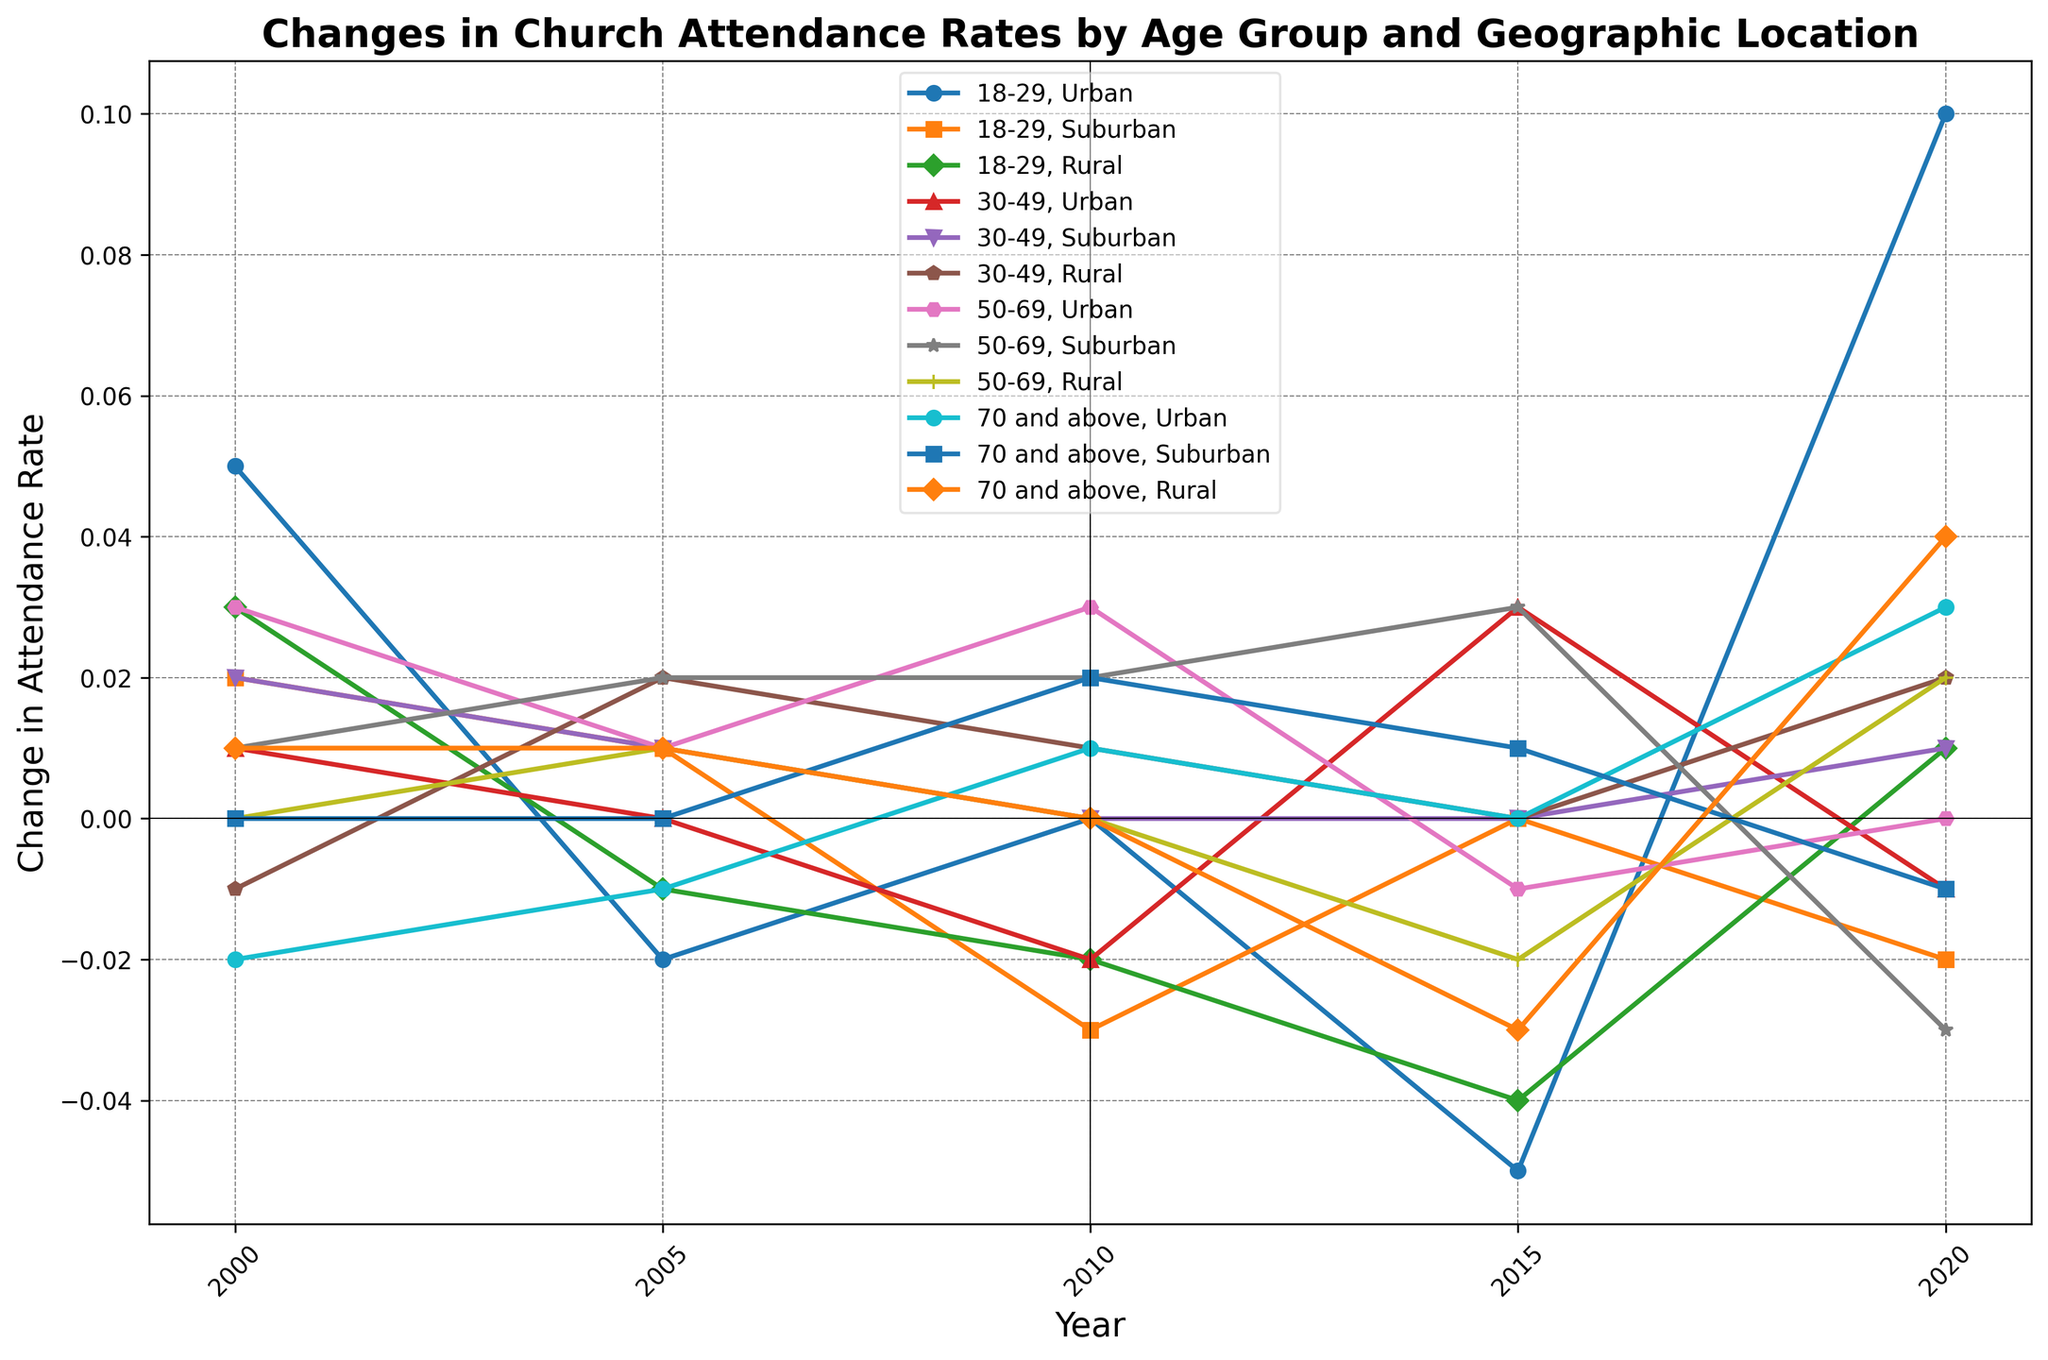What's the trend in church attendance changes for the 18-29 age group in rural areas from 2000 to 2020? The changes in attendance rates for the 18-29 age group in rural areas over the years are as follows: 0.03 (2000), -0.01 (2005), -0.02 (2010), -0.04 (2015), and 0.01 (2020). Despite fluctuations, the attendance generally shows a declining trend with a slight increase in 2020.
Answer: General decline with slight increase in 2020 Which age group and location show the highest increase in church attendance between 2015 and 2020? To find the highest increase, compare the differences between the 2015 and 2020 data for all age group and location combinations. The 70+ age group in Rural areas shows the most significant increase from -0.03 to 0.04, which is a difference of 0.07.
Answer: 70 and above, Rural What was the change in church attendance for the 30-49 age group in urban areas between 2000 and 2020? The attendance rate for the 30-49 age group in urban areas changed from 0.01 in 2000 to -0.01 in 2020. The difference is -0.01 - 0.01 = -0.02.
Answer: -0.02 Comparing the 50-69 age group in suburban and rural areas, which one had a higher change in attendance rate in 2010? In 2010, the change for the 50-69 age group was 0.02 in Suburban areas and 0.00 in Rural areas. Hence, the suburban area had a higher change in attendance.
Answer: Suburban Between 2000 and 2015 for the 18-29 age group, which location saw the least fluctuation in church attendance? We look at the absolute changes in each year for each location (Urban, Suburban, Rural). The least fluctuation comes from Suburban areas with change values of 0.02, 0.01, -0.03, 0.00, totaling 0.06, compared to Urban (total 0.15) and Rural (total 0.10).
Answer: Suburban Which age group and location combination experienced the largest drop in church attendance between the first and last recorded years? To find the largest drop: calculate the differences from 2000 to 2020 for all combinations. The 50-69 age group in Suburban areas fell from 0.01 to -0.03, a drop of -0.04.
Answer: 50-69, Suburban What was the average attendance rate change in rural areas across all age groups in 2020? Calculate the average of the 2020 changes for all age groups in Rural areas: (0.01 + 0.02 + 0.02 + 0.04)/4 = 0.0225.
Answer: 0.0225 Which location had the most volatile attendance rate changes for the 70 and above age group across the given years? Volatility can be deduced from the variation in attendance rates. For the 70+ age group: Urban (0.05), Suburban (0.03), Rural (0.07). Rural shows the highest range (0.07).
Answer: Rural What was the attendance rate change in 2005 for both 18-29 and 30-49 age groups in Urban areas, and which had a higher change? In 2005, the 18-29 Urban group had a change of -0.02, whereas the 30-49 Urban group had 0.00. The 18-29 group had the higher absolute change.
Answer: 18-29 For the 50-69 age group, how does the change in church attendance in 2015 compare between Urban and Suburban areas? In 2015, the change in Urban areas was -0.01 and in Suburban areas it was 0.03. The Suburban area had a higher positive change.
Answer: Suburban 